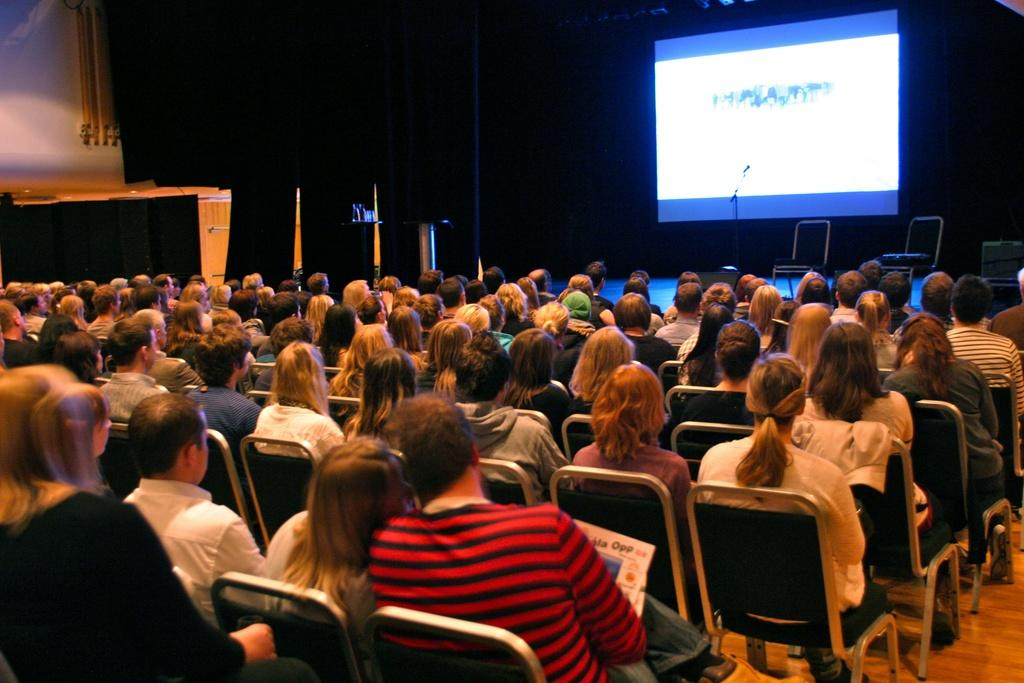What are the people in the image doing? The people in the image are sitting on chairs. Can you describe the setting of the image? The place resembles an auditorium. What can be seen on the stage in the image? There are two chairs and a microphone on the stage. What is the purpose of the screen visible in the image? The purpose of the screen is not specified, but it could be used for presentations or displaying information. Can you tell me how many frogs are sitting on the chairs in the image? There are no frogs present in the image; the people sitting on the chairs are human. What type of fork is being used by the person on stage? There is no fork visible in the image; only chairs, a microphone, and a screen are present. 